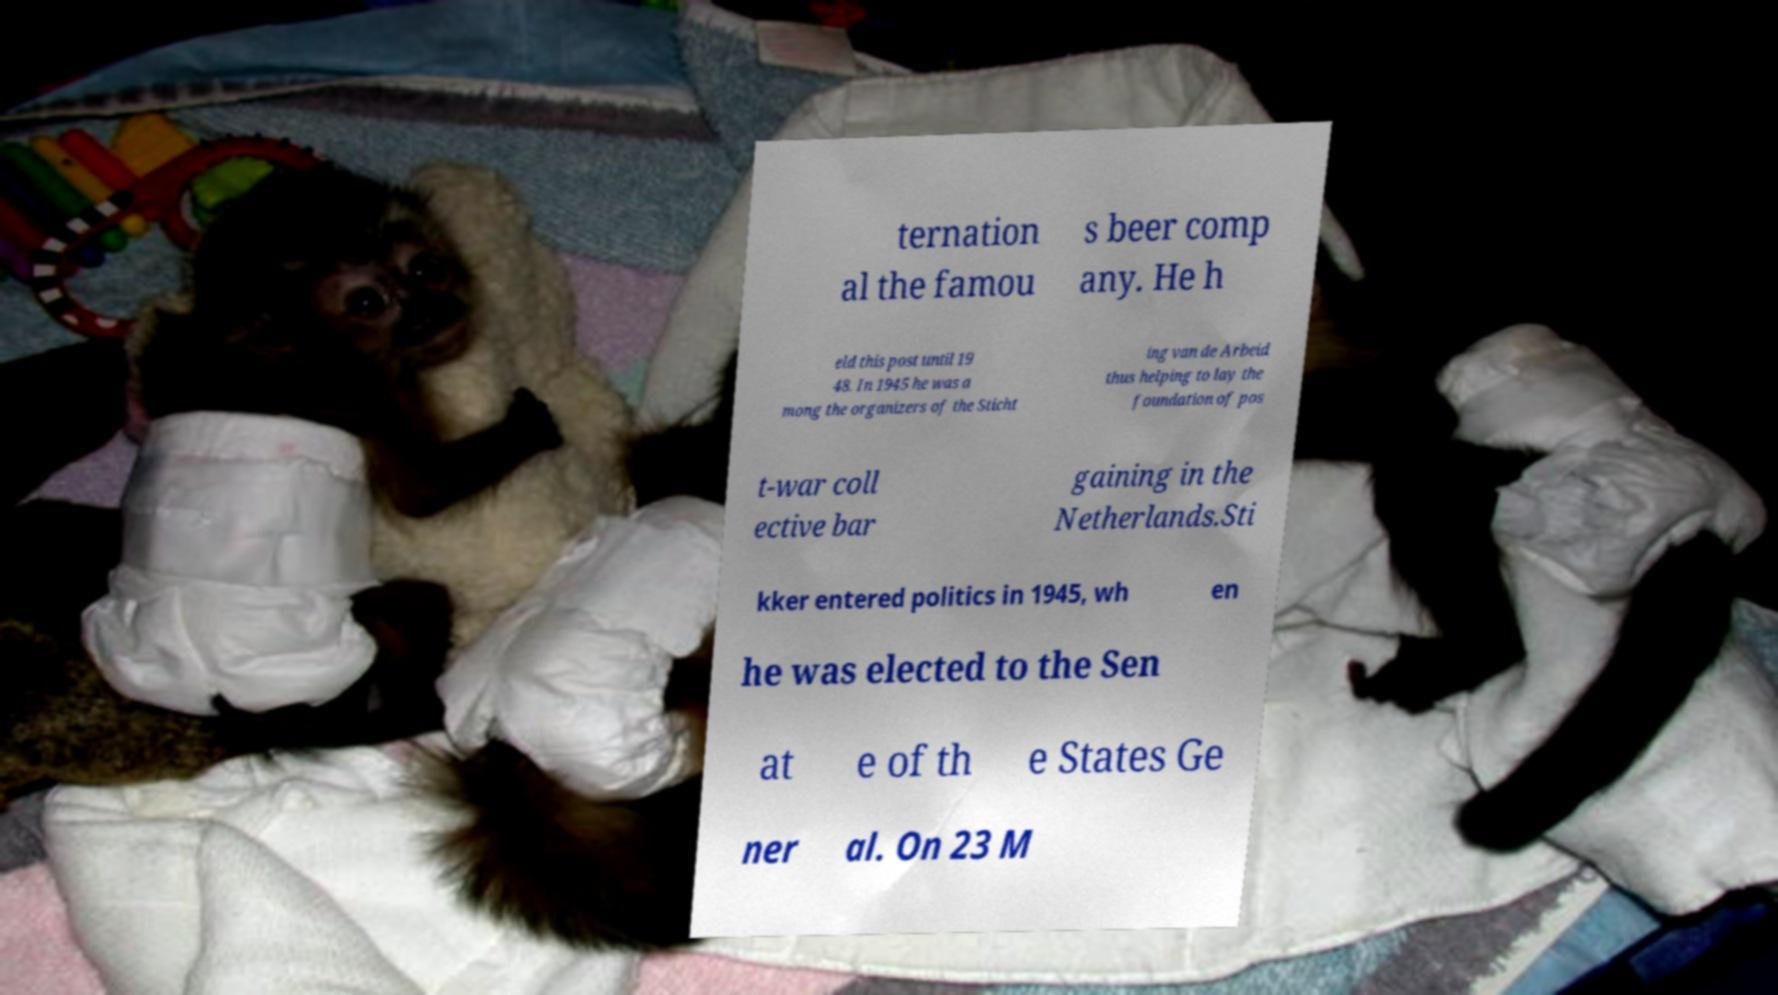For documentation purposes, I need the text within this image transcribed. Could you provide that? ternation al the famou s beer comp any. He h eld this post until 19 48. In 1945 he was a mong the organizers of the Sticht ing van de Arbeid thus helping to lay the foundation of pos t-war coll ective bar gaining in the Netherlands.Sti kker entered politics in 1945, wh en he was elected to the Sen at e of th e States Ge ner al. On 23 M 